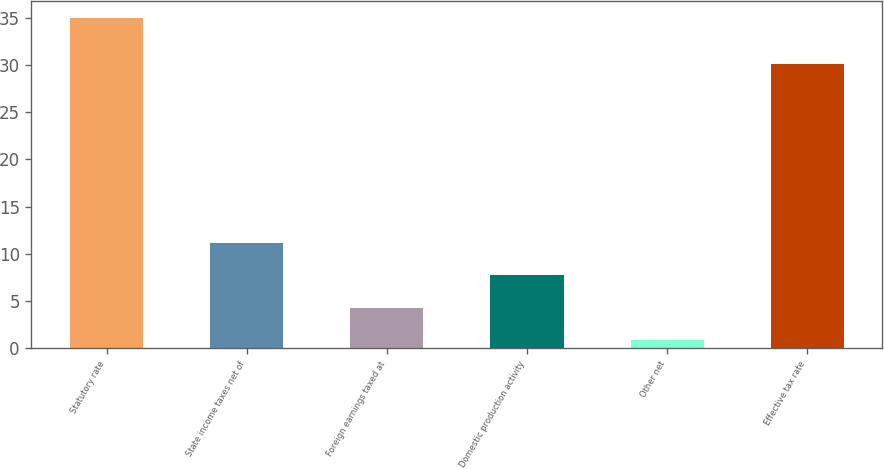Convert chart to OTSL. <chart><loc_0><loc_0><loc_500><loc_500><bar_chart><fcel>Statutory rate<fcel>State income taxes net of<fcel>Foreign earnings taxed at<fcel>Domestic production activity<fcel>Other net<fcel>Effective tax rate<nl><fcel>35<fcel>11.13<fcel>4.31<fcel>7.72<fcel>0.9<fcel>30.1<nl></chart> 